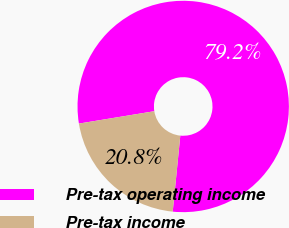Convert chart to OTSL. <chart><loc_0><loc_0><loc_500><loc_500><pie_chart><fcel>Pre-tax operating income<fcel>Pre-tax income<nl><fcel>79.17%<fcel>20.83%<nl></chart> 